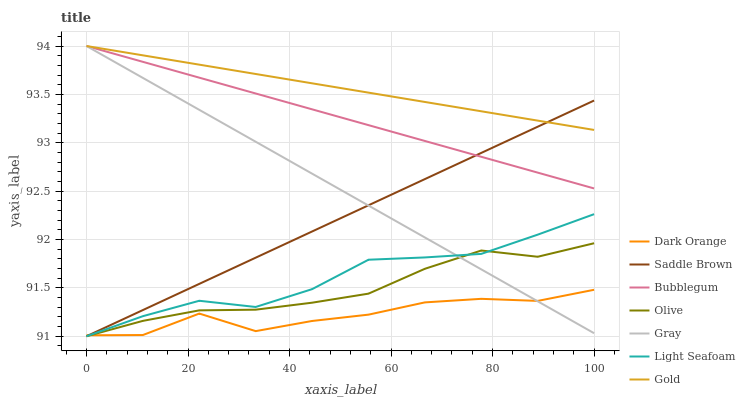Does Gray have the minimum area under the curve?
Answer yes or no. No. Does Gray have the maximum area under the curve?
Answer yes or no. No. Is Gold the smoothest?
Answer yes or no. No. Is Gold the roughest?
Answer yes or no. No. Does Gray have the lowest value?
Answer yes or no. No. Does Olive have the highest value?
Answer yes or no. No. Is Olive less than Gold?
Answer yes or no. Yes. Is Gold greater than Dark Orange?
Answer yes or no. Yes. Does Olive intersect Gold?
Answer yes or no. No. 